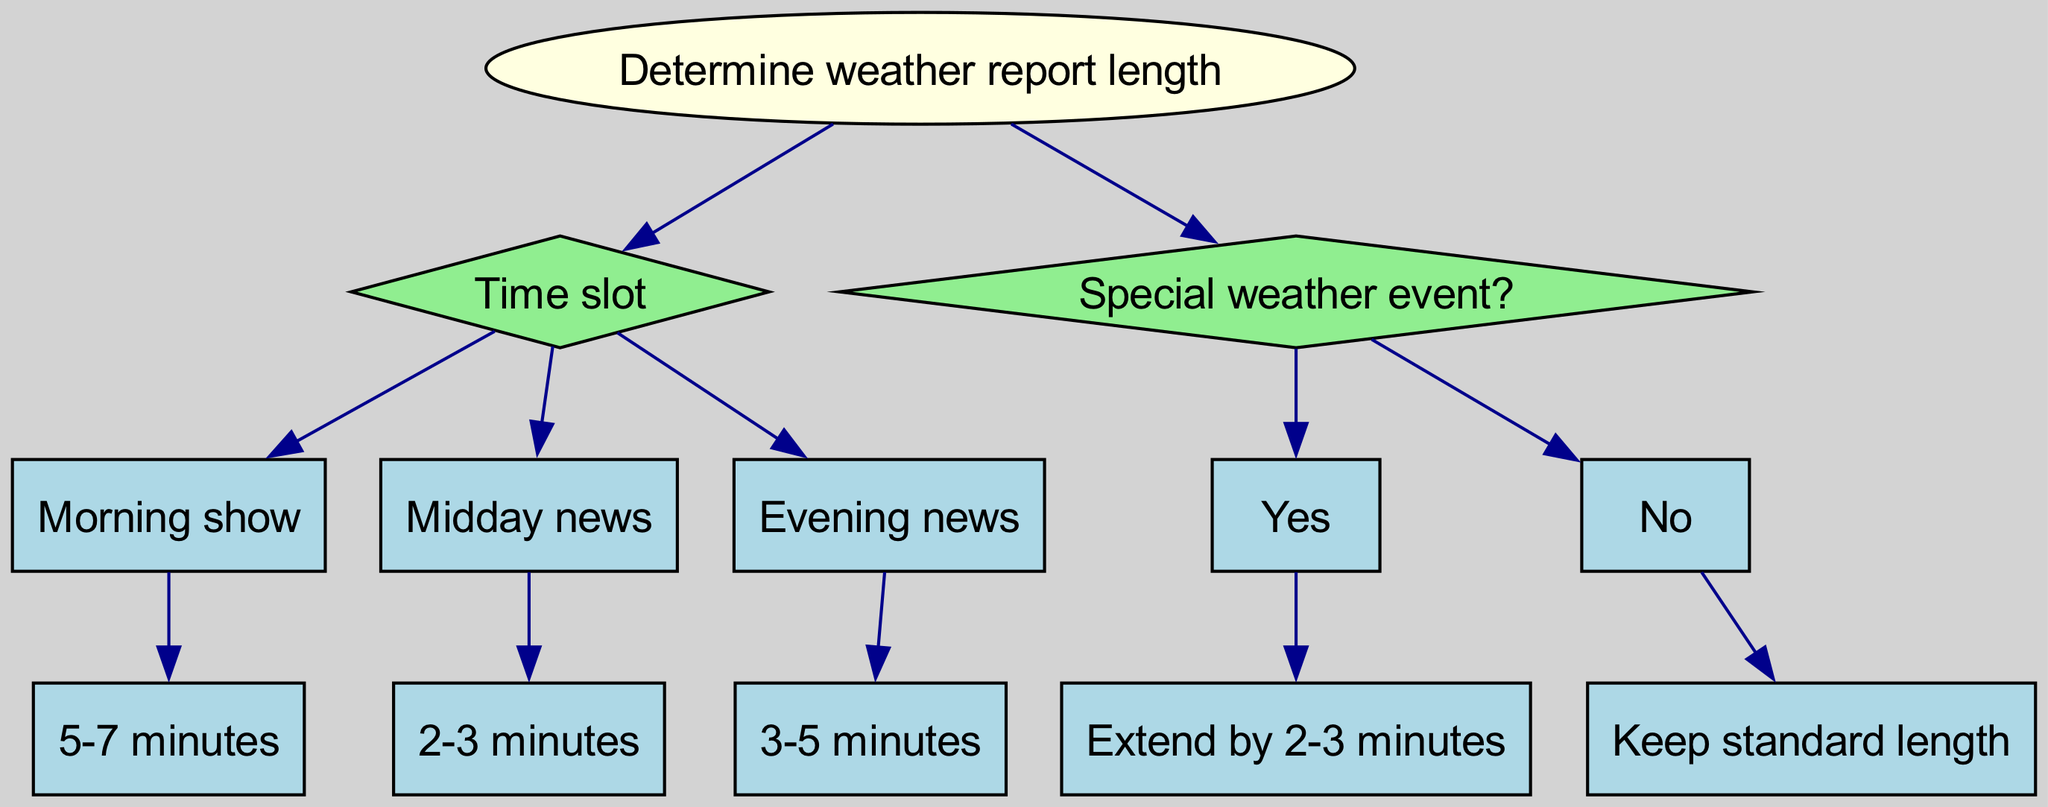What is the root node of the diagram? The root node is labeled "Determine weather report length," which is the starting point of the decision tree.
Answer: Determine weather report length How many total time slots are considered in the diagram? The diagram includes three time slots: morning show, midday news, and evening news, making a total of three time slots.
Answer: 3 What is the weather report length for the evening news? The evening news segment indicates a weather report length of 3-5 minutes, as specified in the evening section of the diagram.
Answer: 3-5 minutes What happens if there is a special weather event? If there is a special weather event, the report length is extended by 2-3 minutes, according to the special weather event part of the diagram.
Answer: Extend by 2-3 minutes What is the report length for the midday news segment? The midday news segment specifies a report length of 2-3 minutes as shown in its respective part of the diagram.
Answer: 2-3 minutes If it is morning and there is no special weather event, what is the report length? For the morning show, if there is no special weather event, the standard report length is 5-7 minutes, as indicated in the morning section of the diagram.
Answer: 5-7 minutes Which time slot is associated with a 2-3 minute report? The midday news is the time slot associated with a report length of 2-3 minutes, as detailed in the midday section of the diagram.
Answer: Midday news If the segment is for evening news and there is a special event, what would be the total report length? For evening news, if there's a special event, you would extend the standard report length of 3-5 minutes by an additional 2-3 minutes, resulting in a total of 5-8 minutes.
Answer: 5-8 minutes 